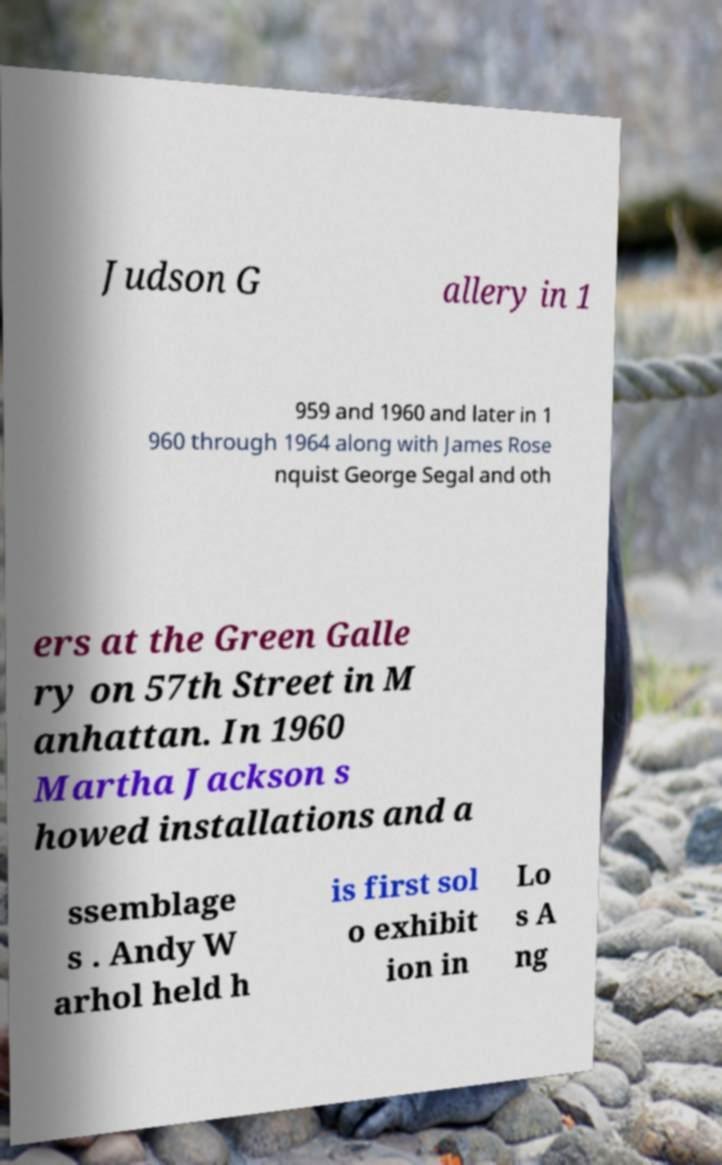Could you extract and type out the text from this image? Judson G allery in 1 959 and 1960 and later in 1 960 through 1964 along with James Rose nquist George Segal and oth ers at the Green Galle ry on 57th Street in M anhattan. In 1960 Martha Jackson s howed installations and a ssemblage s . Andy W arhol held h is first sol o exhibit ion in Lo s A ng 